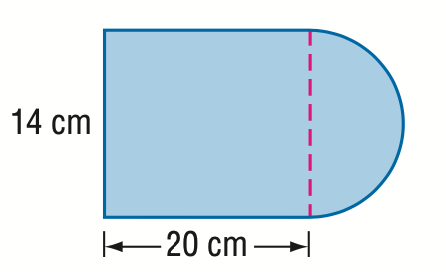Question: Find the area of the composite figure. Round to the nearest tenth.
Choices:
A. 217.0
B. 293.9
C. 357.0
D. 433.9
Answer with the letter. Answer: C 